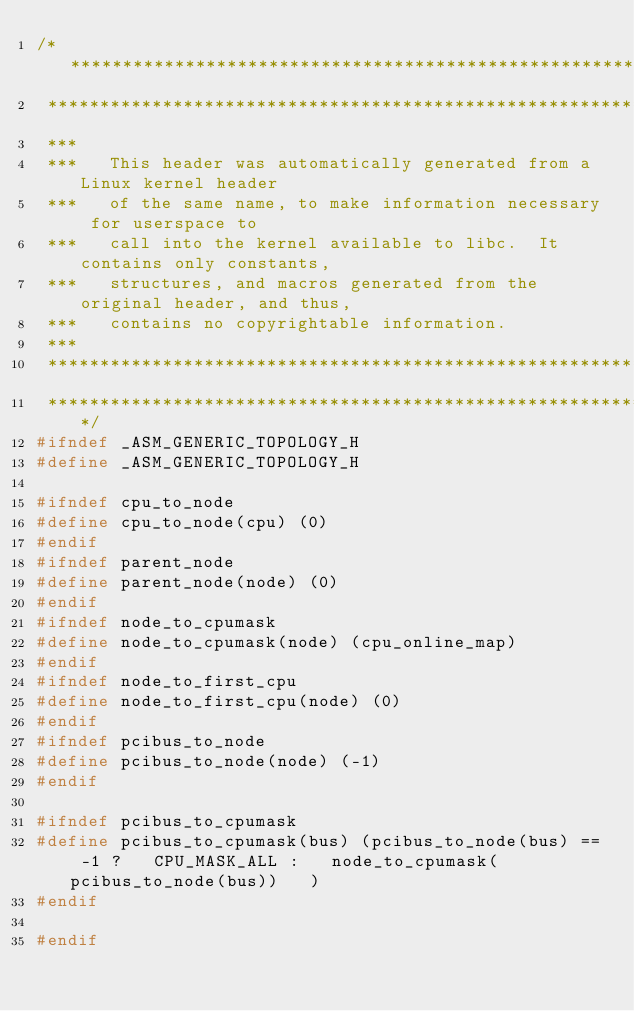Convert code to text. <code><loc_0><loc_0><loc_500><loc_500><_C_>/****************************************************************************
 ****************************************************************************
 ***
 ***   This header was automatically generated from a Linux kernel header
 ***   of the same name, to make information necessary for userspace to
 ***   call into the kernel available to libc.  It contains only constants,
 ***   structures, and macros generated from the original header, and thus,
 ***   contains no copyrightable information.
 ***
 ****************************************************************************
 ****************************************************************************/
#ifndef _ASM_GENERIC_TOPOLOGY_H
#define _ASM_GENERIC_TOPOLOGY_H

#ifndef cpu_to_node
#define cpu_to_node(cpu) (0)
#endif
#ifndef parent_node
#define parent_node(node) (0)
#endif
#ifndef node_to_cpumask
#define node_to_cpumask(node) (cpu_online_map)
#endif
#ifndef node_to_first_cpu
#define node_to_first_cpu(node) (0)
#endif
#ifndef pcibus_to_node
#define pcibus_to_node(node) (-1)
#endif

#ifndef pcibus_to_cpumask
#define pcibus_to_cpumask(bus) (pcibus_to_node(bus) == -1 ?   CPU_MASK_ALL :   node_to_cpumask(pcibus_to_node(bus))   )
#endif

#endif
</code> 